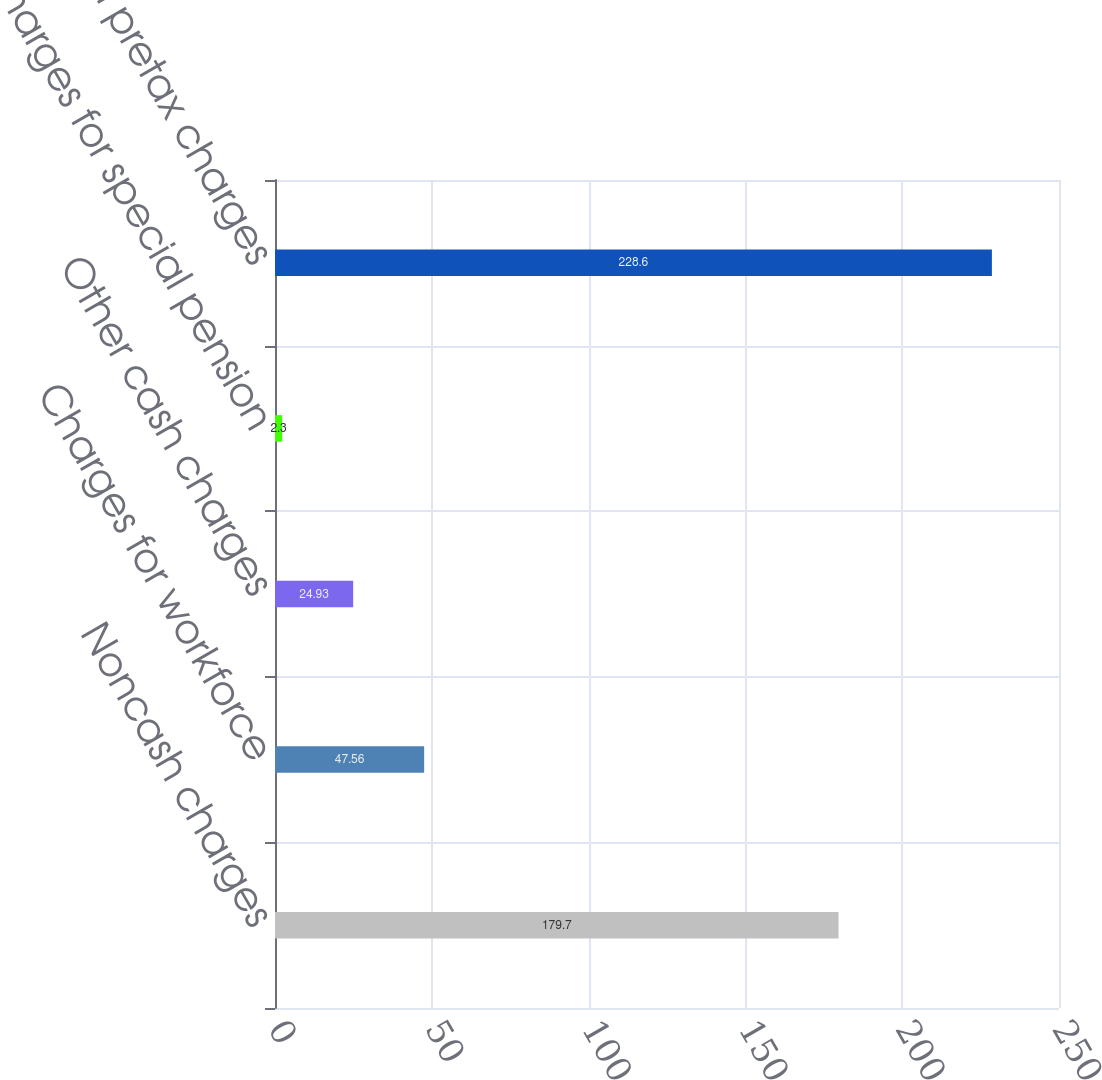<chart> <loc_0><loc_0><loc_500><loc_500><bar_chart><fcel>Noncash charges<fcel>Charges for workforce<fcel>Other cash charges<fcel>Charges for special pension<fcel>Total pretax charges<nl><fcel>179.7<fcel>47.56<fcel>24.93<fcel>2.3<fcel>228.6<nl></chart> 